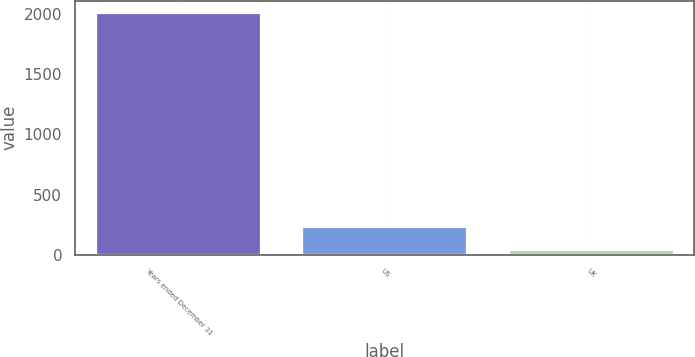<chart> <loc_0><loc_0><loc_500><loc_500><bar_chart><fcel>Years ended December 31<fcel>US<fcel>UK<nl><fcel>2010<fcel>232.5<fcel>35<nl></chart> 